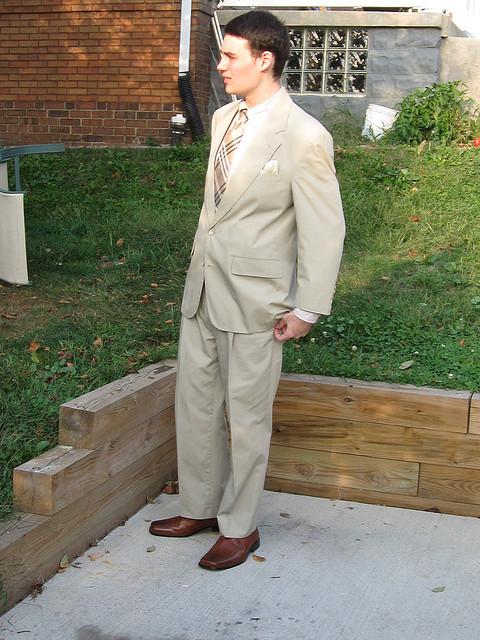What type of suit is this?
Concise answer only. Business. What color is the man's suit?
Give a very brief answer. Cream. Where can one buy a suit like that?
Be succinct. Department store. 